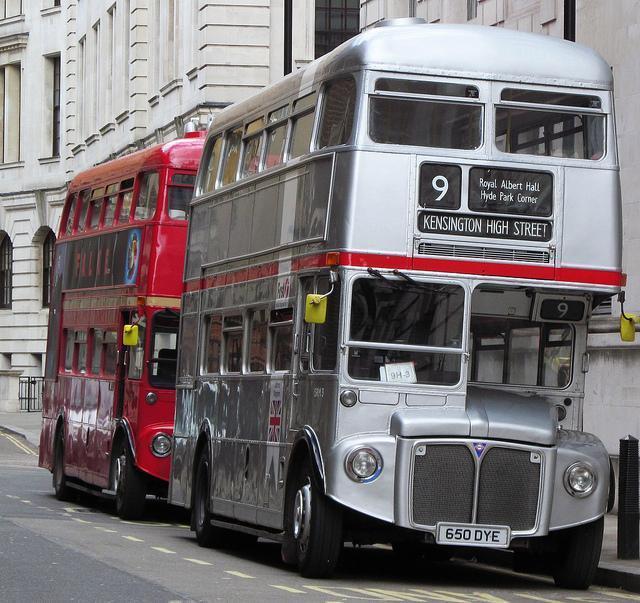How many buses are shown?
Give a very brief answer. 2. How many buses are there?
Give a very brief answer. 2. How many buses are shown in this picture?
Give a very brief answer. 2. How many buses can you see?
Give a very brief answer. 2. How many women are wearing pink?
Give a very brief answer. 0. 